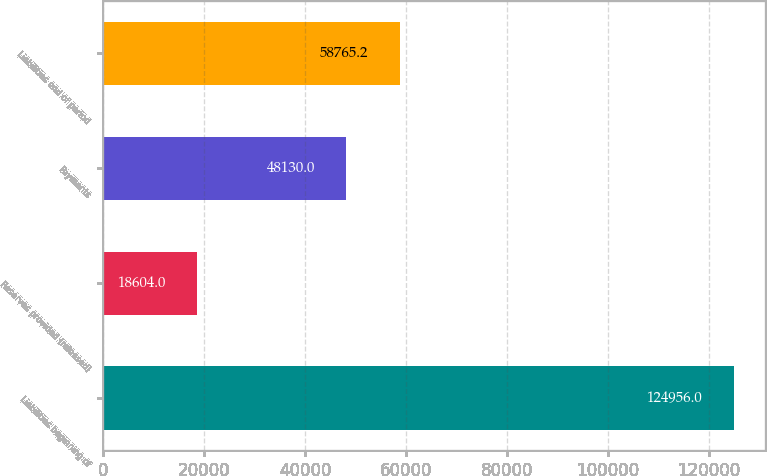Convert chart. <chart><loc_0><loc_0><loc_500><loc_500><bar_chart><fcel>Liabilities beginning of<fcel>Reserves provided (released)<fcel>Payments<fcel>Liabilities end of period<nl><fcel>124956<fcel>18604<fcel>48130<fcel>58765.2<nl></chart> 